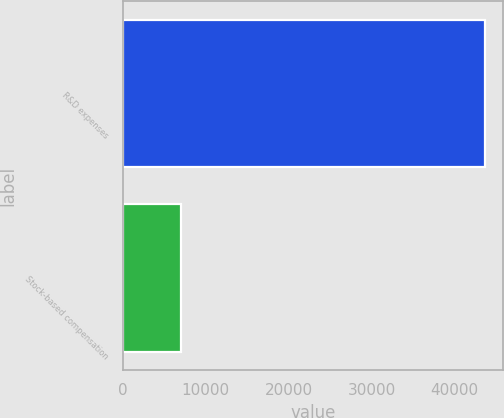Convert chart. <chart><loc_0><loc_0><loc_500><loc_500><bar_chart><fcel>R&D expenses<fcel>Stock-based compensation<nl><fcel>43690<fcel>7078<nl></chart> 